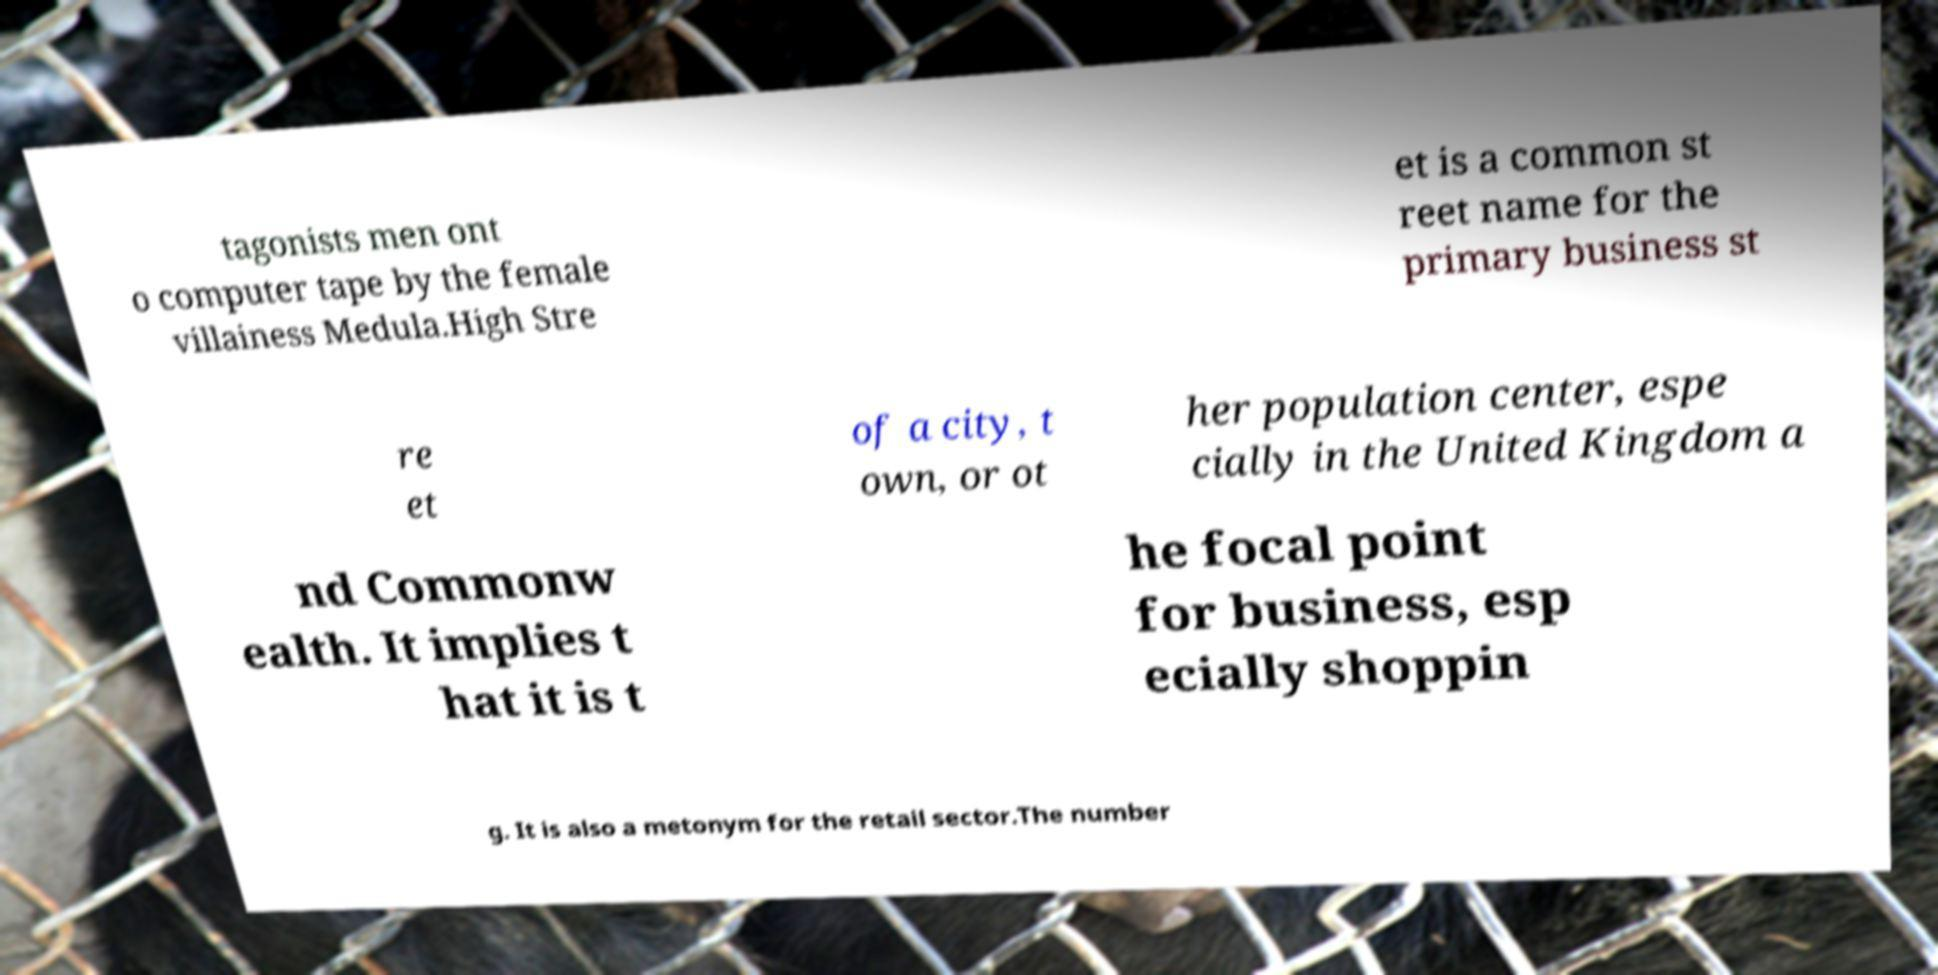Please read and relay the text visible in this image. What does it say? tagonists men ont o computer tape by the female villainess Medula.High Stre et is a common st reet name for the primary business st re et of a city, t own, or ot her population center, espe cially in the United Kingdom a nd Commonw ealth. It implies t hat it is t he focal point for business, esp ecially shoppin g. It is also a metonym for the retail sector.The number 